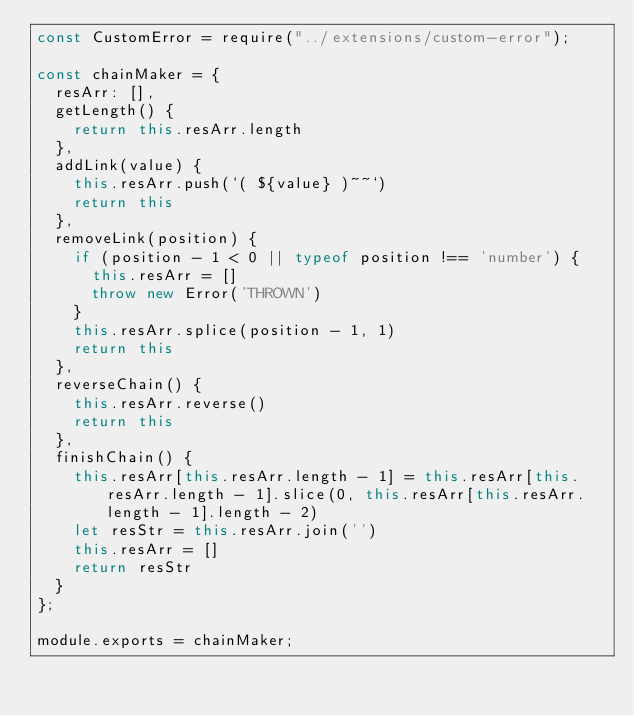<code> <loc_0><loc_0><loc_500><loc_500><_JavaScript_>const CustomError = require("../extensions/custom-error");

const chainMaker = {
  resArr: [],
  getLength() {
    return this.resArr.length
  },
  addLink(value) {
    this.resArr.push(`( ${value} )~~`)
    return this
  },
  removeLink(position) {
    if (position - 1 < 0 || typeof position !== 'number') {
      this.resArr = []
      throw new Error('THROWN')
    }
    this.resArr.splice(position - 1, 1)
    return this
  },
  reverseChain() {
    this.resArr.reverse()
    return this
  },
  finishChain() {
    this.resArr[this.resArr.length - 1] = this.resArr[this.resArr.length - 1].slice(0, this.resArr[this.resArr.length - 1].length - 2)
    let resStr = this.resArr.join('')
    this.resArr = []
    return resStr
  }
};

module.exports = chainMaker;
</code> 